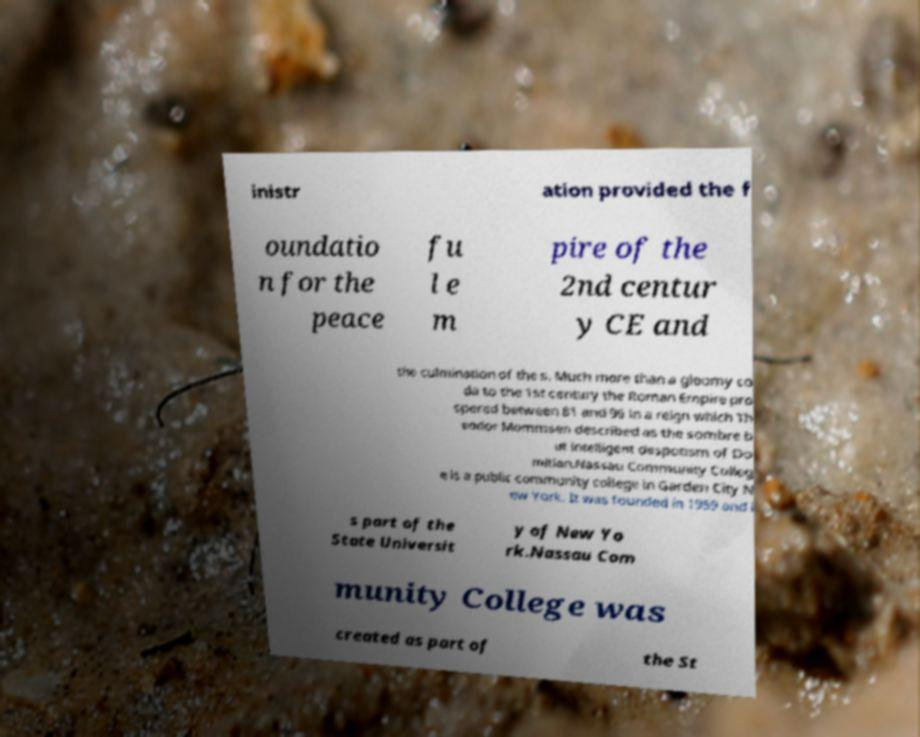Could you assist in decoding the text presented in this image and type it out clearly? inistr ation provided the f oundatio n for the peace fu l e m pire of the 2nd centur y CE and the culmination of the s. Much more than a gloomy co da to the 1st century the Roman Empire pro spered between 81 and 96 in a reign which Th eodor Mommsen described as the sombre b ut intelligent despotism of Do mitian.Nassau Community Colleg e is a public community college in Garden City N ew York. It was founded in 1959 and i s part of the State Universit y of New Yo rk.Nassau Com munity College was created as part of the St 